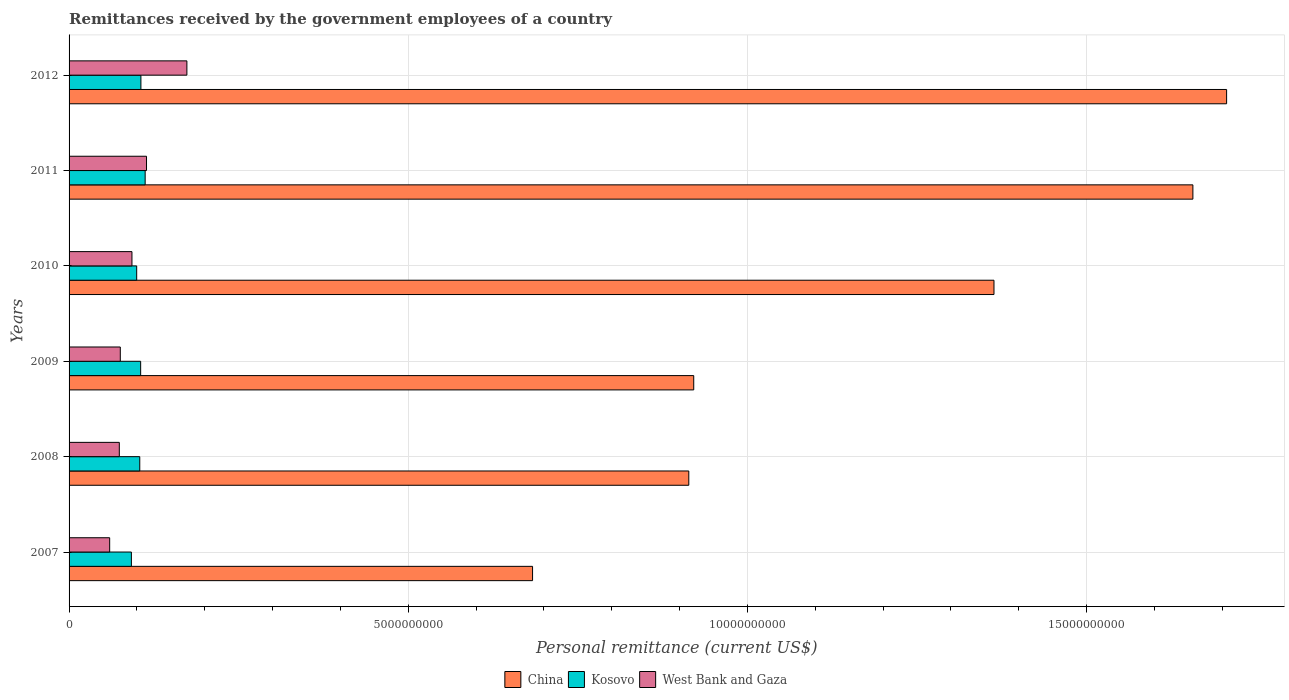How many different coloured bars are there?
Keep it short and to the point. 3. How many bars are there on the 4th tick from the top?
Give a very brief answer. 3. What is the label of the 3rd group of bars from the top?
Your answer should be compact. 2010. In how many cases, is the number of bars for a given year not equal to the number of legend labels?
Offer a very short reply. 0. What is the remittances received by the government employees in West Bank and Gaza in 2007?
Offer a very short reply. 5.99e+08. Across all years, what is the maximum remittances received by the government employees in China?
Ensure brevity in your answer.  1.71e+1. Across all years, what is the minimum remittances received by the government employees in West Bank and Gaza?
Your response must be concise. 5.99e+08. In which year was the remittances received by the government employees in Kosovo maximum?
Your response must be concise. 2011. What is the total remittances received by the government employees in China in the graph?
Provide a succinct answer. 7.24e+1. What is the difference between the remittances received by the government employees in West Bank and Gaza in 2007 and that in 2009?
Give a very brief answer. -1.57e+08. What is the difference between the remittances received by the government employees in West Bank and Gaza in 2010 and the remittances received by the government employees in China in 2009?
Keep it short and to the point. -8.28e+09. What is the average remittances received by the government employees in Kosovo per year?
Provide a short and direct response. 1.03e+09. In the year 2009, what is the difference between the remittances received by the government employees in China and remittances received by the government employees in Kosovo?
Keep it short and to the point. 8.15e+09. What is the ratio of the remittances received by the government employees in West Bank and Gaza in 2010 to that in 2012?
Your response must be concise. 0.53. Is the difference between the remittances received by the government employees in China in 2008 and 2012 greater than the difference between the remittances received by the government employees in Kosovo in 2008 and 2012?
Provide a succinct answer. No. What is the difference between the highest and the second highest remittances received by the government employees in Kosovo?
Ensure brevity in your answer.  6.26e+07. What is the difference between the highest and the lowest remittances received by the government employees in West Bank and Gaza?
Your response must be concise. 1.14e+09. Is the sum of the remittances received by the government employees in China in 2008 and 2010 greater than the maximum remittances received by the government employees in Kosovo across all years?
Give a very brief answer. Yes. What does the 2nd bar from the top in 2012 represents?
Provide a succinct answer. Kosovo. What does the 2nd bar from the bottom in 2011 represents?
Your answer should be compact. Kosovo. Is it the case that in every year, the sum of the remittances received by the government employees in China and remittances received by the government employees in West Bank and Gaza is greater than the remittances received by the government employees in Kosovo?
Provide a succinct answer. Yes. How many bars are there?
Offer a very short reply. 18. How many years are there in the graph?
Offer a terse response. 6. Are the values on the major ticks of X-axis written in scientific E-notation?
Provide a short and direct response. No. Where does the legend appear in the graph?
Make the answer very short. Bottom center. What is the title of the graph?
Offer a very short reply. Remittances received by the government employees of a country. What is the label or title of the X-axis?
Keep it short and to the point. Personal remittance (current US$). What is the Personal remittance (current US$) in China in 2007?
Ensure brevity in your answer.  6.83e+09. What is the Personal remittance (current US$) of Kosovo in 2007?
Provide a short and direct response. 9.19e+08. What is the Personal remittance (current US$) in West Bank and Gaza in 2007?
Provide a succinct answer. 5.99e+08. What is the Personal remittance (current US$) of China in 2008?
Provide a short and direct response. 9.14e+09. What is the Personal remittance (current US$) in Kosovo in 2008?
Keep it short and to the point. 1.04e+09. What is the Personal remittance (current US$) in West Bank and Gaza in 2008?
Your answer should be very brief. 7.41e+08. What is the Personal remittance (current US$) of China in 2009?
Make the answer very short. 9.21e+09. What is the Personal remittance (current US$) in Kosovo in 2009?
Ensure brevity in your answer.  1.06e+09. What is the Personal remittance (current US$) in West Bank and Gaza in 2009?
Give a very brief answer. 7.55e+08. What is the Personal remittance (current US$) in China in 2010?
Make the answer very short. 1.36e+1. What is the Personal remittance (current US$) in Kosovo in 2010?
Keep it short and to the point. 9.97e+08. What is the Personal remittance (current US$) in West Bank and Gaza in 2010?
Offer a terse response. 9.27e+08. What is the Personal remittance (current US$) of China in 2011?
Your answer should be compact. 1.66e+1. What is the Personal remittance (current US$) in Kosovo in 2011?
Your answer should be very brief. 1.12e+09. What is the Personal remittance (current US$) in West Bank and Gaza in 2011?
Ensure brevity in your answer.  1.14e+09. What is the Personal remittance (current US$) of China in 2012?
Your answer should be very brief. 1.71e+1. What is the Personal remittance (current US$) in Kosovo in 2012?
Give a very brief answer. 1.06e+09. What is the Personal remittance (current US$) in West Bank and Gaza in 2012?
Your answer should be very brief. 1.74e+09. Across all years, what is the maximum Personal remittance (current US$) in China?
Your answer should be compact. 1.71e+1. Across all years, what is the maximum Personal remittance (current US$) in Kosovo?
Provide a succinct answer. 1.12e+09. Across all years, what is the maximum Personal remittance (current US$) in West Bank and Gaza?
Make the answer very short. 1.74e+09. Across all years, what is the minimum Personal remittance (current US$) of China?
Provide a short and direct response. 6.83e+09. Across all years, what is the minimum Personal remittance (current US$) in Kosovo?
Give a very brief answer. 9.19e+08. Across all years, what is the minimum Personal remittance (current US$) of West Bank and Gaza?
Provide a succinct answer. 5.99e+08. What is the total Personal remittance (current US$) in China in the graph?
Make the answer very short. 7.24e+1. What is the total Personal remittance (current US$) of Kosovo in the graph?
Offer a terse response. 6.19e+09. What is the total Personal remittance (current US$) in West Bank and Gaza in the graph?
Keep it short and to the point. 5.90e+09. What is the difference between the Personal remittance (current US$) in China in 2007 and that in 2008?
Give a very brief answer. -2.30e+09. What is the difference between the Personal remittance (current US$) of Kosovo in 2007 and that in 2008?
Your response must be concise. -1.24e+08. What is the difference between the Personal remittance (current US$) of West Bank and Gaza in 2007 and that in 2008?
Your response must be concise. -1.42e+08. What is the difference between the Personal remittance (current US$) in China in 2007 and that in 2009?
Offer a very short reply. -2.38e+09. What is the difference between the Personal remittance (current US$) in Kosovo in 2007 and that in 2009?
Provide a succinct answer. -1.37e+08. What is the difference between the Personal remittance (current US$) in West Bank and Gaza in 2007 and that in 2009?
Your response must be concise. -1.57e+08. What is the difference between the Personal remittance (current US$) in China in 2007 and that in 2010?
Offer a terse response. -6.80e+09. What is the difference between the Personal remittance (current US$) in Kosovo in 2007 and that in 2010?
Keep it short and to the point. -7.82e+07. What is the difference between the Personal remittance (current US$) of West Bank and Gaza in 2007 and that in 2010?
Make the answer very short. -3.29e+08. What is the difference between the Personal remittance (current US$) in China in 2007 and that in 2011?
Offer a terse response. -9.74e+09. What is the difference between the Personal remittance (current US$) of Kosovo in 2007 and that in 2011?
Give a very brief answer. -2.03e+08. What is the difference between the Personal remittance (current US$) of West Bank and Gaza in 2007 and that in 2011?
Your answer should be very brief. -5.43e+08. What is the difference between the Personal remittance (current US$) of China in 2007 and that in 2012?
Offer a terse response. -1.02e+1. What is the difference between the Personal remittance (current US$) in Kosovo in 2007 and that in 2012?
Your response must be concise. -1.40e+08. What is the difference between the Personal remittance (current US$) of West Bank and Gaza in 2007 and that in 2012?
Your answer should be very brief. -1.14e+09. What is the difference between the Personal remittance (current US$) of China in 2008 and that in 2009?
Give a very brief answer. -7.29e+07. What is the difference between the Personal remittance (current US$) in Kosovo in 2008 and that in 2009?
Your response must be concise. -1.30e+07. What is the difference between the Personal remittance (current US$) in West Bank and Gaza in 2008 and that in 2009?
Give a very brief answer. -1.45e+07. What is the difference between the Personal remittance (current US$) in China in 2008 and that in 2010?
Offer a terse response. -4.50e+09. What is the difference between the Personal remittance (current US$) in Kosovo in 2008 and that in 2010?
Offer a terse response. 4.54e+07. What is the difference between the Personal remittance (current US$) in West Bank and Gaza in 2008 and that in 2010?
Ensure brevity in your answer.  -1.86e+08. What is the difference between the Personal remittance (current US$) of China in 2008 and that in 2011?
Give a very brief answer. -7.43e+09. What is the difference between the Personal remittance (current US$) of Kosovo in 2008 and that in 2011?
Keep it short and to the point. -7.93e+07. What is the difference between the Personal remittance (current US$) in West Bank and Gaza in 2008 and that in 2011?
Give a very brief answer. -4.01e+08. What is the difference between the Personal remittance (current US$) of China in 2008 and that in 2012?
Offer a very short reply. -7.93e+09. What is the difference between the Personal remittance (current US$) in Kosovo in 2008 and that in 2012?
Provide a short and direct response. -1.67e+07. What is the difference between the Personal remittance (current US$) in West Bank and Gaza in 2008 and that in 2012?
Your response must be concise. -9.96e+08. What is the difference between the Personal remittance (current US$) in China in 2009 and that in 2010?
Offer a terse response. -4.43e+09. What is the difference between the Personal remittance (current US$) of Kosovo in 2009 and that in 2010?
Your answer should be compact. 5.84e+07. What is the difference between the Personal remittance (current US$) of West Bank and Gaza in 2009 and that in 2010?
Keep it short and to the point. -1.72e+08. What is the difference between the Personal remittance (current US$) of China in 2009 and that in 2011?
Your answer should be very brief. -7.36e+09. What is the difference between the Personal remittance (current US$) in Kosovo in 2009 and that in 2011?
Offer a very short reply. -6.64e+07. What is the difference between the Personal remittance (current US$) of West Bank and Gaza in 2009 and that in 2011?
Offer a very short reply. -3.86e+08. What is the difference between the Personal remittance (current US$) of China in 2009 and that in 2012?
Offer a very short reply. -7.86e+09. What is the difference between the Personal remittance (current US$) of Kosovo in 2009 and that in 2012?
Offer a very short reply. -3.76e+06. What is the difference between the Personal remittance (current US$) of West Bank and Gaza in 2009 and that in 2012?
Make the answer very short. -9.82e+08. What is the difference between the Personal remittance (current US$) in China in 2010 and that in 2011?
Offer a terse response. -2.93e+09. What is the difference between the Personal remittance (current US$) in Kosovo in 2010 and that in 2011?
Your answer should be very brief. -1.25e+08. What is the difference between the Personal remittance (current US$) of West Bank and Gaza in 2010 and that in 2011?
Provide a short and direct response. -2.15e+08. What is the difference between the Personal remittance (current US$) of China in 2010 and that in 2012?
Offer a terse response. -3.43e+09. What is the difference between the Personal remittance (current US$) of Kosovo in 2010 and that in 2012?
Ensure brevity in your answer.  -6.21e+07. What is the difference between the Personal remittance (current US$) of West Bank and Gaza in 2010 and that in 2012?
Provide a succinct answer. -8.10e+08. What is the difference between the Personal remittance (current US$) of China in 2011 and that in 2012?
Provide a succinct answer. -4.97e+08. What is the difference between the Personal remittance (current US$) of Kosovo in 2011 and that in 2012?
Provide a succinct answer. 6.26e+07. What is the difference between the Personal remittance (current US$) in West Bank and Gaza in 2011 and that in 2012?
Ensure brevity in your answer.  -5.95e+08. What is the difference between the Personal remittance (current US$) in China in 2007 and the Personal remittance (current US$) in Kosovo in 2008?
Your answer should be very brief. 5.79e+09. What is the difference between the Personal remittance (current US$) in China in 2007 and the Personal remittance (current US$) in West Bank and Gaza in 2008?
Provide a short and direct response. 6.09e+09. What is the difference between the Personal remittance (current US$) in Kosovo in 2007 and the Personal remittance (current US$) in West Bank and Gaza in 2008?
Offer a terse response. 1.78e+08. What is the difference between the Personal remittance (current US$) of China in 2007 and the Personal remittance (current US$) of Kosovo in 2009?
Make the answer very short. 5.78e+09. What is the difference between the Personal remittance (current US$) in China in 2007 and the Personal remittance (current US$) in West Bank and Gaza in 2009?
Your answer should be compact. 6.08e+09. What is the difference between the Personal remittance (current US$) of Kosovo in 2007 and the Personal remittance (current US$) of West Bank and Gaza in 2009?
Your answer should be very brief. 1.63e+08. What is the difference between the Personal remittance (current US$) in China in 2007 and the Personal remittance (current US$) in Kosovo in 2010?
Make the answer very short. 5.84e+09. What is the difference between the Personal remittance (current US$) in China in 2007 and the Personal remittance (current US$) in West Bank and Gaza in 2010?
Provide a short and direct response. 5.91e+09. What is the difference between the Personal remittance (current US$) of Kosovo in 2007 and the Personal remittance (current US$) of West Bank and Gaza in 2010?
Provide a succinct answer. -8.46e+06. What is the difference between the Personal remittance (current US$) of China in 2007 and the Personal remittance (current US$) of Kosovo in 2011?
Your answer should be compact. 5.71e+09. What is the difference between the Personal remittance (current US$) of China in 2007 and the Personal remittance (current US$) of West Bank and Gaza in 2011?
Give a very brief answer. 5.69e+09. What is the difference between the Personal remittance (current US$) of Kosovo in 2007 and the Personal remittance (current US$) of West Bank and Gaza in 2011?
Give a very brief answer. -2.23e+08. What is the difference between the Personal remittance (current US$) in China in 2007 and the Personal remittance (current US$) in Kosovo in 2012?
Your answer should be compact. 5.77e+09. What is the difference between the Personal remittance (current US$) of China in 2007 and the Personal remittance (current US$) of West Bank and Gaza in 2012?
Provide a short and direct response. 5.10e+09. What is the difference between the Personal remittance (current US$) of Kosovo in 2007 and the Personal remittance (current US$) of West Bank and Gaza in 2012?
Make the answer very short. -8.18e+08. What is the difference between the Personal remittance (current US$) of China in 2008 and the Personal remittance (current US$) of Kosovo in 2009?
Make the answer very short. 8.08e+09. What is the difference between the Personal remittance (current US$) of China in 2008 and the Personal remittance (current US$) of West Bank and Gaza in 2009?
Your response must be concise. 8.38e+09. What is the difference between the Personal remittance (current US$) of Kosovo in 2008 and the Personal remittance (current US$) of West Bank and Gaza in 2009?
Offer a very short reply. 2.87e+08. What is the difference between the Personal remittance (current US$) in China in 2008 and the Personal remittance (current US$) in Kosovo in 2010?
Provide a short and direct response. 8.14e+09. What is the difference between the Personal remittance (current US$) in China in 2008 and the Personal remittance (current US$) in West Bank and Gaza in 2010?
Ensure brevity in your answer.  8.21e+09. What is the difference between the Personal remittance (current US$) in Kosovo in 2008 and the Personal remittance (current US$) in West Bank and Gaza in 2010?
Your answer should be very brief. 1.15e+08. What is the difference between the Personal remittance (current US$) of China in 2008 and the Personal remittance (current US$) of Kosovo in 2011?
Your answer should be compact. 8.01e+09. What is the difference between the Personal remittance (current US$) of China in 2008 and the Personal remittance (current US$) of West Bank and Gaza in 2011?
Give a very brief answer. 7.99e+09. What is the difference between the Personal remittance (current US$) of Kosovo in 2008 and the Personal remittance (current US$) of West Bank and Gaza in 2011?
Provide a short and direct response. -9.94e+07. What is the difference between the Personal remittance (current US$) in China in 2008 and the Personal remittance (current US$) in Kosovo in 2012?
Your answer should be compact. 8.08e+09. What is the difference between the Personal remittance (current US$) in China in 2008 and the Personal remittance (current US$) in West Bank and Gaza in 2012?
Keep it short and to the point. 7.40e+09. What is the difference between the Personal remittance (current US$) of Kosovo in 2008 and the Personal remittance (current US$) of West Bank and Gaza in 2012?
Offer a terse response. -6.95e+08. What is the difference between the Personal remittance (current US$) in China in 2009 and the Personal remittance (current US$) in Kosovo in 2010?
Ensure brevity in your answer.  8.21e+09. What is the difference between the Personal remittance (current US$) of China in 2009 and the Personal remittance (current US$) of West Bank and Gaza in 2010?
Your response must be concise. 8.28e+09. What is the difference between the Personal remittance (current US$) in Kosovo in 2009 and the Personal remittance (current US$) in West Bank and Gaza in 2010?
Offer a terse response. 1.28e+08. What is the difference between the Personal remittance (current US$) in China in 2009 and the Personal remittance (current US$) in Kosovo in 2011?
Make the answer very short. 8.09e+09. What is the difference between the Personal remittance (current US$) of China in 2009 and the Personal remittance (current US$) of West Bank and Gaza in 2011?
Provide a short and direct response. 8.07e+09. What is the difference between the Personal remittance (current US$) of Kosovo in 2009 and the Personal remittance (current US$) of West Bank and Gaza in 2011?
Your answer should be compact. -8.64e+07. What is the difference between the Personal remittance (current US$) in China in 2009 and the Personal remittance (current US$) in Kosovo in 2012?
Provide a succinct answer. 8.15e+09. What is the difference between the Personal remittance (current US$) of China in 2009 and the Personal remittance (current US$) of West Bank and Gaza in 2012?
Your answer should be very brief. 7.47e+09. What is the difference between the Personal remittance (current US$) in Kosovo in 2009 and the Personal remittance (current US$) in West Bank and Gaza in 2012?
Offer a very short reply. -6.82e+08. What is the difference between the Personal remittance (current US$) in China in 2010 and the Personal remittance (current US$) in Kosovo in 2011?
Give a very brief answer. 1.25e+1. What is the difference between the Personal remittance (current US$) in China in 2010 and the Personal remittance (current US$) in West Bank and Gaza in 2011?
Your answer should be very brief. 1.25e+1. What is the difference between the Personal remittance (current US$) in Kosovo in 2010 and the Personal remittance (current US$) in West Bank and Gaza in 2011?
Provide a short and direct response. -1.45e+08. What is the difference between the Personal remittance (current US$) in China in 2010 and the Personal remittance (current US$) in Kosovo in 2012?
Offer a terse response. 1.26e+1. What is the difference between the Personal remittance (current US$) of China in 2010 and the Personal remittance (current US$) of West Bank and Gaza in 2012?
Ensure brevity in your answer.  1.19e+1. What is the difference between the Personal remittance (current US$) of Kosovo in 2010 and the Personal remittance (current US$) of West Bank and Gaza in 2012?
Offer a very short reply. -7.40e+08. What is the difference between the Personal remittance (current US$) in China in 2011 and the Personal remittance (current US$) in Kosovo in 2012?
Your response must be concise. 1.55e+1. What is the difference between the Personal remittance (current US$) in China in 2011 and the Personal remittance (current US$) in West Bank and Gaza in 2012?
Offer a terse response. 1.48e+1. What is the difference between the Personal remittance (current US$) in Kosovo in 2011 and the Personal remittance (current US$) in West Bank and Gaza in 2012?
Provide a succinct answer. -6.15e+08. What is the average Personal remittance (current US$) of China per year?
Provide a short and direct response. 1.21e+1. What is the average Personal remittance (current US$) in Kosovo per year?
Offer a very short reply. 1.03e+09. What is the average Personal remittance (current US$) in West Bank and Gaza per year?
Make the answer very short. 9.83e+08. In the year 2007, what is the difference between the Personal remittance (current US$) of China and Personal remittance (current US$) of Kosovo?
Ensure brevity in your answer.  5.91e+09. In the year 2007, what is the difference between the Personal remittance (current US$) in China and Personal remittance (current US$) in West Bank and Gaza?
Provide a short and direct response. 6.23e+09. In the year 2007, what is the difference between the Personal remittance (current US$) of Kosovo and Personal remittance (current US$) of West Bank and Gaza?
Keep it short and to the point. 3.20e+08. In the year 2008, what is the difference between the Personal remittance (current US$) of China and Personal remittance (current US$) of Kosovo?
Give a very brief answer. 8.09e+09. In the year 2008, what is the difference between the Personal remittance (current US$) in China and Personal remittance (current US$) in West Bank and Gaza?
Ensure brevity in your answer.  8.40e+09. In the year 2008, what is the difference between the Personal remittance (current US$) in Kosovo and Personal remittance (current US$) in West Bank and Gaza?
Provide a short and direct response. 3.02e+08. In the year 2009, what is the difference between the Personal remittance (current US$) in China and Personal remittance (current US$) in Kosovo?
Offer a very short reply. 8.15e+09. In the year 2009, what is the difference between the Personal remittance (current US$) in China and Personal remittance (current US$) in West Bank and Gaza?
Make the answer very short. 8.45e+09. In the year 2009, what is the difference between the Personal remittance (current US$) in Kosovo and Personal remittance (current US$) in West Bank and Gaza?
Keep it short and to the point. 3.00e+08. In the year 2010, what is the difference between the Personal remittance (current US$) of China and Personal remittance (current US$) of Kosovo?
Offer a very short reply. 1.26e+1. In the year 2010, what is the difference between the Personal remittance (current US$) in China and Personal remittance (current US$) in West Bank and Gaza?
Make the answer very short. 1.27e+1. In the year 2010, what is the difference between the Personal remittance (current US$) of Kosovo and Personal remittance (current US$) of West Bank and Gaza?
Your answer should be compact. 6.98e+07. In the year 2011, what is the difference between the Personal remittance (current US$) in China and Personal remittance (current US$) in Kosovo?
Your answer should be compact. 1.54e+1. In the year 2011, what is the difference between the Personal remittance (current US$) of China and Personal remittance (current US$) of West Bank and Gaza?
Your answer should be very brief. 1.54e+1. In the year 2011, what is the difference between the Personal remittance (current US$) of Kosovo and Personal remittance (current US$) of West Bank and Gaza?
Give a very brief answer. -2.01e+07. In the year 2012, what is the difference between the Personal remittance (current US$) in China and Personal remittance (current US$) in Kosovo?
Offer a terse response. 1.60e+1. In the year 2012, what is the difference between the Personal remittance (current US$) in China and Personal remittance (current US$) in West Bank and Gaza?
Your response must be concise. 1.53e+1. In the year 2012, what is the difference between the Personal remittance (current US$) in Kosovo and Personal remittance (current US$) in West Bank and Gaza?
Provide a short and direct response. -6.78e+08. What is the ratio of the Personal remittance (current US$) in China in 2007 to that in 2008?
Give a very brief answer. 0.75. What is the ratio of the Personal remittance (current US$) in Kosovo in 2007 to that in 2008?
Your answer should be very brief. 0.88. What is the ratio of the Personal remittance (current US$) of West Bank and Gaza in 2007 to that in 2008?
Make the answer very short. 0.81. What is the ratio of the Personal remittance (current US$) in China in 2007 to that in 2009?
Offer a very short reply. 0.74. What is the ratio of the Personal remittance (current US$) of Kosovo in 2007 to that in 2009?
Offer a very short reply. 0.87. What is the ratio of the Personal remittance (current US$) of West Bank and Gaza in 2007 to that in 2009?
Offer a terse response. 0.79. What is the ratio of the Personal remittance (current US$) of China in 2007 to that in 2010?
Your response must be concise. 0.5. What is the ratio of the Personal remittance (current US$) in Kosovo in 2007 to that in 2010?
Make the answer very short. 0.92. What is the ratio of the Personal remittance (current US$) of West Bank and Gaza in 2007 to that in 2010?
Your answer should be compact. 0.65. What is the ratio of the Personal remittance (current US$) in China in 2007 to that in 2011?
Offer a terse response. 0.41. What is the ratio of the Personal remittance (current US$) in Kosovo in 2007 to that in 2011?
Your response must be concise. 0.82. What is the ratio of the Personal remittance (current US$) in West Bank and Gaza in 2007 to that in 2011?
Offer a terse response. 0.52. What is the ratio of the Personal remittance (current US$) in China in 2007 to that in 2012?
Ensure brevity in your answer.  0.4. What is the ratio of the Personal remittance (current US$) in Kosovo in 2007 to that in 2012?
Offer a very short reply. 0.87. What is the ratio of the Personal remittance (current US$) of West Bank and Gaza in 2007 to that in 2012?
Make the answer very short. 0.34. What is the ratio of the Personal remittance (current US$) in China in 2008 to that in 2009?
Provide a succinct answer. 0.99. What is the ratio of the Personal remittance (current US$) in Kosovo in 2008 to that in 2009?
Offer a very short reply. 0.99. What is the ratio of the Personal remittance (current US$) in West Bank and Gaza in 2008 to that in 2009?
Offer a very short reply. 0.98. What is the ratio of the Personal remittance (current US$) in China in 2008 to that in 2010?
Give a very brief answer. 0.67. What is the ratio of the Personal remittance (current US$) of Kosovo in 2008 to that in 2010?
Offer a very short reply. 1.05. What is the ratio of the Personal remittance (current US$) in West Bank and Gaza in 2008 to that in 2010?
Ensure brevity in your answer.  0.8. What is the ratio of the Personal remittance (current US$) of China in 2008 to that in 2011?
Keep it short and to the point. 0.55. What is the ratio of the Personal remittance (current US$) in Kosovo in 2008 to that in 2011?
Ensure brevity in your answer.  0.93. What is the ratio of the Personal remittance (current US$) in West Bank and Gaza in 2008 to that in 2011?
Give a very brief answer. 0.65. What is the ratio of the Personal remittance (current US$) of China in 2008 to that in 2012?
Your response must be concise. 0.54. What is the ratio of the Personal remittance (current US$) in Kosovo in 2008 to that in 2012?
Make the answer very short. 0.98. What is the ratio of the Personal remittance (current US$) of West Bank and Gaza in 2008 to that in 2012?
Give a very brief answer. 0.43. What is the ratio of the Personal remittance (current US$) in China in 2009 to that in 2010?
Offer a terse response. 0.68. What is the ratio of the Personal remittance (current US$) of Kosovo in 2009 to that in 2010?
Provide a short and direct response. 1.06. What is the ratio of the Personal remittance (current US$) in West Bank and Gaza in 2009 to that in 2010?
Provide a short and direct response. 0.81. What is the ratio of the Personal remittance (current US$) of China in 2009 to that in 2011?
Provide a short and direct response. 0.56. What is the ratio of the Personal remittance (current US$) in Kosovo in 2009 to that in 2011?
Offer a terse response. 0.94. What is the ratio of the Personal remittance (current US$) in West Bank and Gaza in 2009 to that in 2011?
Your answer should be very brief. 0.66. What is the ratio of the Personal remittance (current US$) of China in 2009 to that in 2012?
Your answer should be very brief. 0.54. What is the ratio of the Personal remittance (current US$) of West Bank and Gaza in 2009 to that in 2012?
Your answer should be compact. 0.43. What is the ratio of the Personal remittance (current US$) in China in 2010 to that in 2011?
Your answer should be compact. 0.82. What is the ratio of the Personal remittance (current US$) of Kosovo in 2010 to that in 2011?
Your answer should be compact. 0.89. What is the ratio of the Personal remittance (current US$) of West Bank and Gaza in 2010 to that in 2011?
Your response must be concise. 0.81. What is the ratio of the Personal remittance (current US$) in China in 2010 to that in 2012?
Your answer should be compact. 0.8. What is the ratio of the Personal remittance (current US$) in Kosovo in 2010 to that in 2012?
Your answer should be compact. 0.94. What is the ratio of the Personal remittance (current US$) of West Bank and Gaza in 2010 to that in 2012?
Give a very brief answer. 0.53. What is the ratio of the Personal remittance (current US$) of China in 2011 to that in 2012?
Make the answer very short. 0.97. What is the ratio of the Personal remittance (current US$) in Kosovo in 2011 to that in 2012?
Offer a very short reply. 1.06. What is the ratio of the Personal remittance (current US$) of West Bank and Gaza in 2011 to that in 2012?
Provide a short and direct response. 0.66. What is the difference between the highest and the second highest Personal remittance (current US$) in China?
Ensure brevity in your answer.  4.97e+08. What is the difference between the highest and the second highest Personal remittance (current US$) in Kosovo?
Offer a terse response. 6.26e+07. What is the difference between the highest and the second highest Personal remittance (current US$) of West Bank and Gaza?
Give a very brief answer. 5.95e+08. What is the difference between the highest and the lowest Personal remittance (current US$) in China?
Provide a succinct answer. 1.02e+1. What is the difference between the highest and the lowest Personal remittance (current US$) in Kosovo?
Your answer should be compact. 2.03e+08. What is the difference between the highest and the lowest Personal remittance (current US$) in West Bank and Gaza?
Make the answer very short. 1.14e+09. 